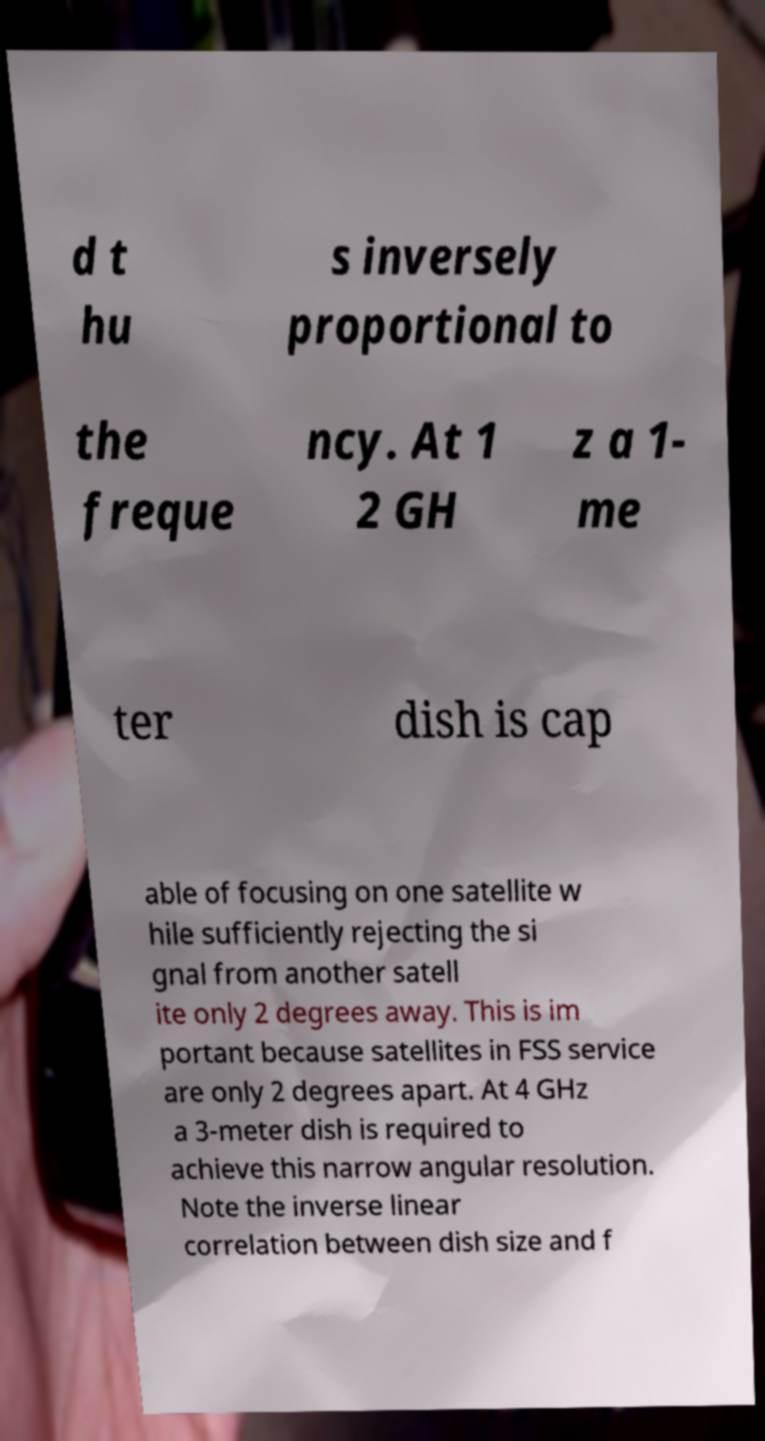Can you read and provide the text displayed in the image?This photo seems to have some interesting text. Can you extract and type it out for me? d t hu s inversely proportional to the freque ncy. At 1 2 GH z a 1- me ter dish is cap able of focusing on one satellite w hile sufficiently rejecting the si gnal from another satell ite only 2 degrees away. This is im portant because satellites in FSS service are only 2 degrees apart. At 4 GHz a 3-meter dish is required to achieve this narrow angular resolution. Note the inverse linear correlation between dish size and f 